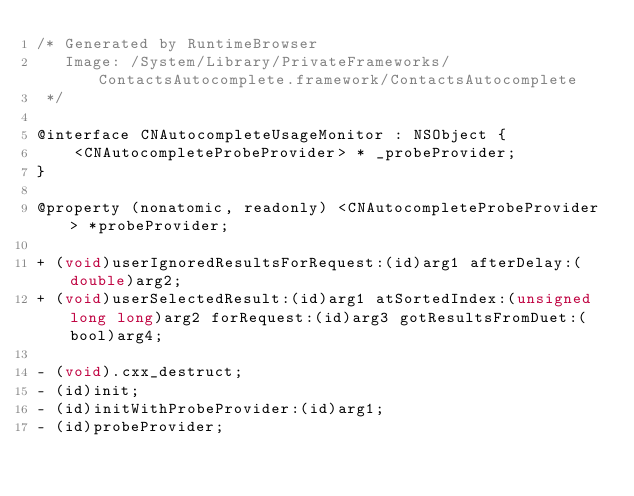Convert code to text. <code><loc_0><loc_0><loc_500><loc_500><_C_>/* Generated by RuntimeBrowser
   Image: /System/Library/PrivateFrameworks/ContactsAutocomplete.framework/ContactsAutocomplete
 */

@interface CNAutocompleteUsageMonitor : NSObject {
    <CNAutocompleteProbeProvider> * _probeProvider;
}

@property (nonatomic, readonly) <CNAutocompleteProbeProvider> *probeProvider;

+ (void)userIgnoredResultsForRequest:(id)arg1 afterDelay:(double)arg2;
+ (void)userSelectedResult:(id)arg1 atSortedIndex:(unsigned long long)arg2 forRequest:(id)arg3 gotResultsFromDuet:(bool)arg4;

- (void).cxx_destruct;
- (id)init;
- (id)initWithProbeProvider:(id)arg1;
- (id)probeProvider;</code> 